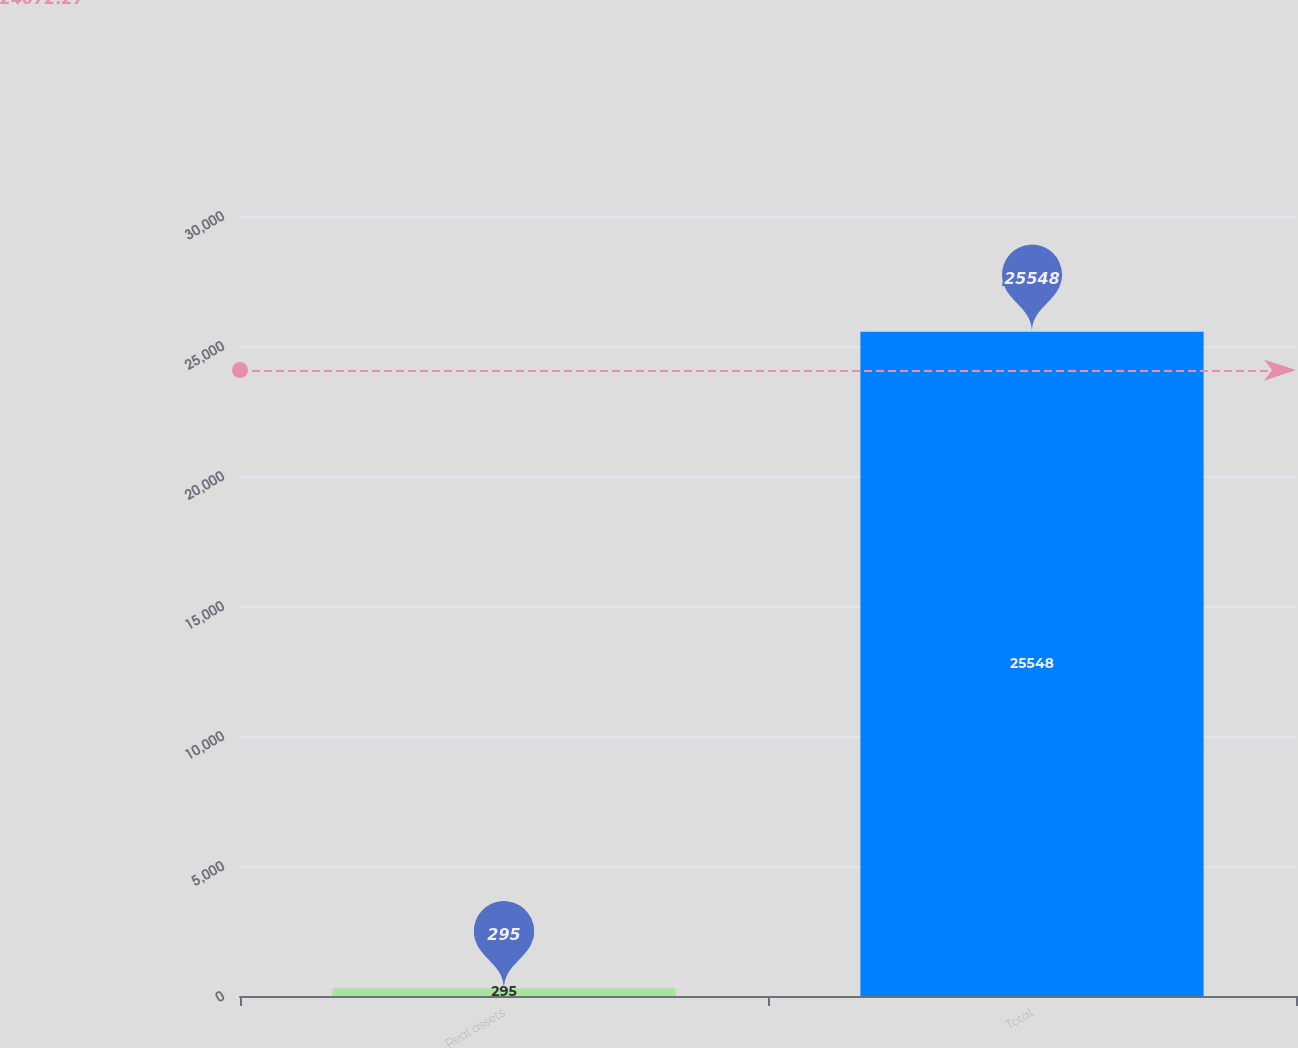<chart> <loc_0><loc_0><loc_500><loc_500><bar_chart><fcel>Real assets<fcel>Total<nl><fcel>295<fcel>25548<nl></chart> 